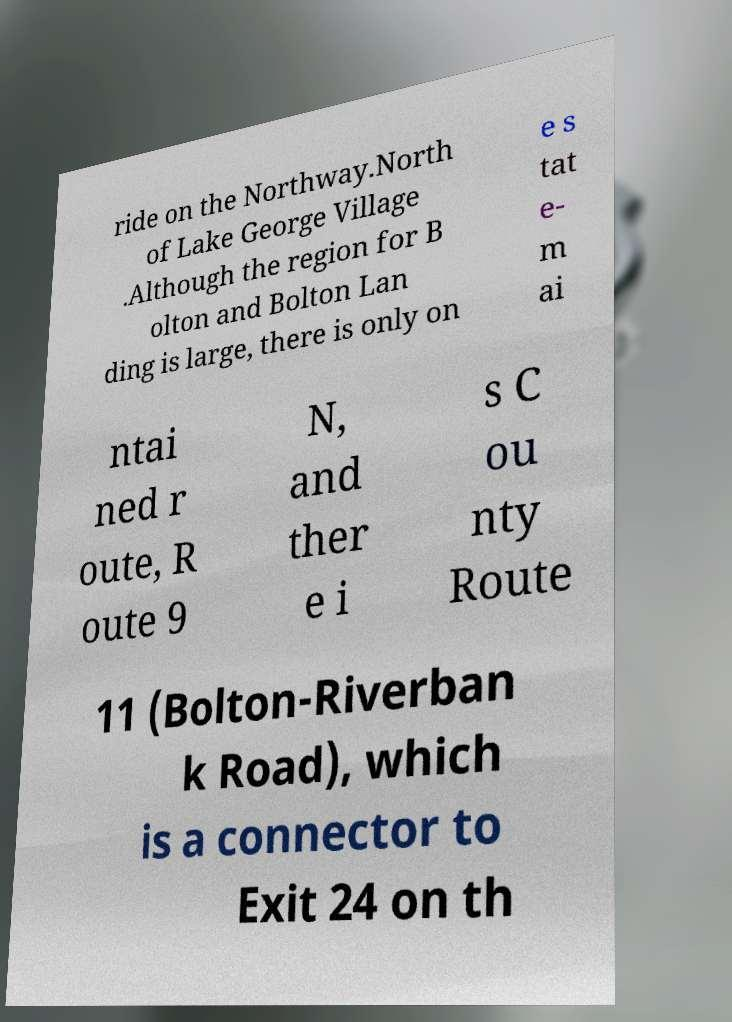Could you assist in decoding the text presented in this image and type it out clearly? ride on the Northway.North of Lake George Village .Although the region for B olton and Bolton Lan ding is large, there is only on e s tat e- m ai ntai ned r oute, R oute 9 N, and ther e i s C ou nty Route 11 (Bolton-Riverban k Road), which is a connector to Exit 24 on th 